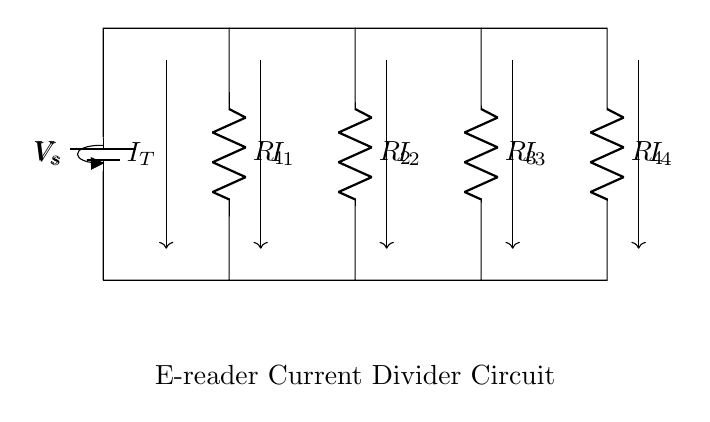What is the total current entering the circuit? The total current, denoted as I_T, represents the current supplied by the battery, and it's indicated by the arrow entering at the top left of the circuit diagram.
Answer: I_T How many resistors are in series with the voltage supply? The voltage supply is connected to multiple resistors, but they form parallel paths. Each resistor is not in series with the battery but rather in parallel; however, the sum of all branches will equal the current supplied by the battery.
Answer: Four Which resistor has the highest resistance? To determine which resistor has the highest resistance, one would need the values of R_1, R_2, R_3, and R_4. The visual diagram does not provide these values; thus, the answer cannot be discerned solely from the diagram.
Answer: Not determinable What is the relationship between the currents in the resistors? According to the Current Divider Rule, the currents through the resistors are inversely proportional to their resistances, meaning that the resistor with the least resistance will have the highest current.
Answer: Inversely proportional What happens to the total current if one resistor fails? If one resistor fails and creates an open circuit in that branch, the total current will decrease because it will no longer share the total current with that branch, thereby reducing the overall current flowing through the circuit.
Answer: Decreases 